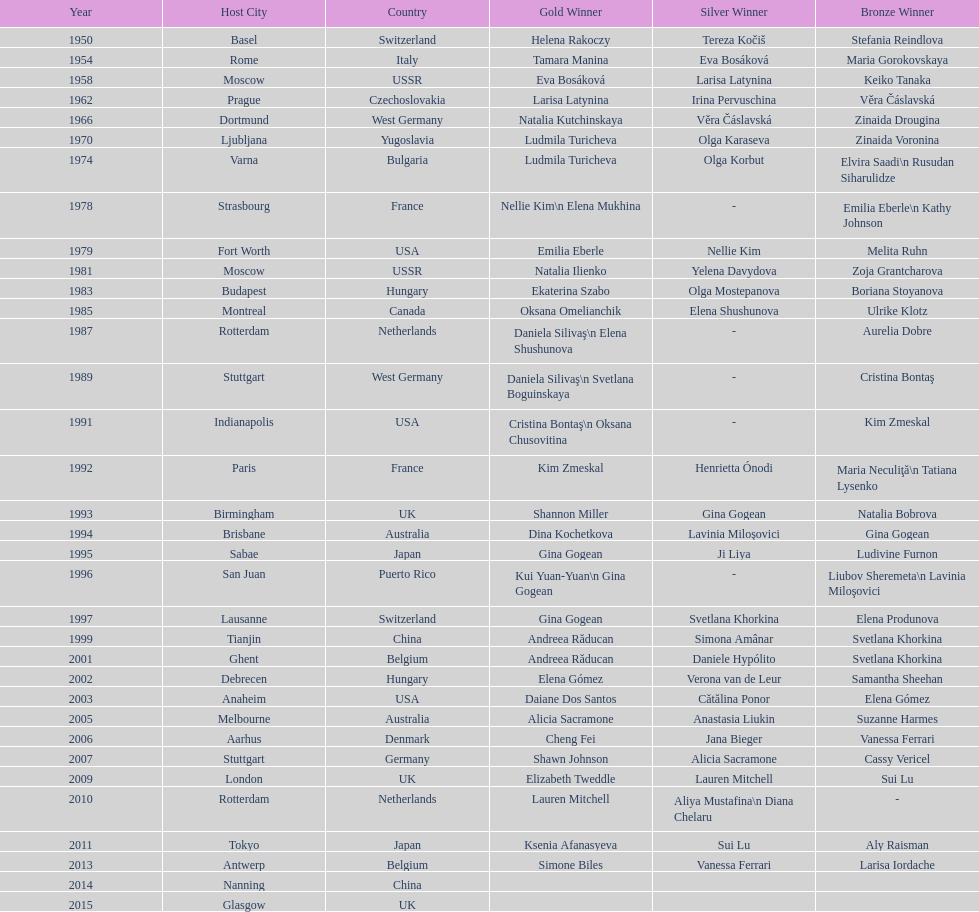Where were the championships held before the 1962 prague championships? Moscow. 